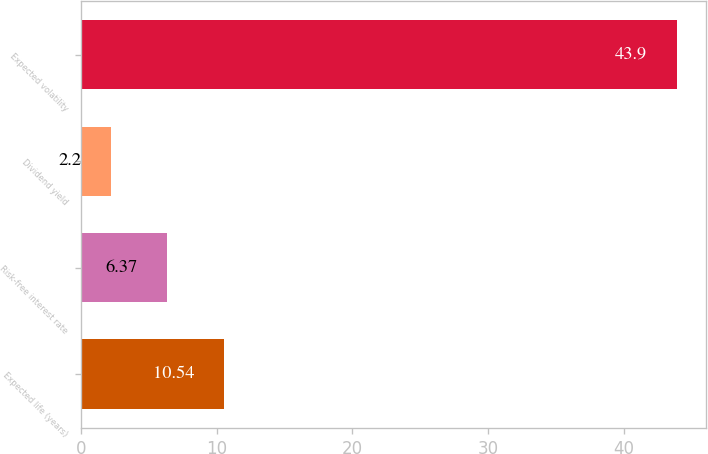<chart> <loc_0><loc_0><loc_500><loc_500><bar_chart><fcel>Expected life (years)<fcel>Risk-free interest rate<fcel>Dividend yield<fcel>Expected volatility<nl><fcel>10.54<fcel>6.37<fcel>2.2<fcel>43.9<nl></chart> 